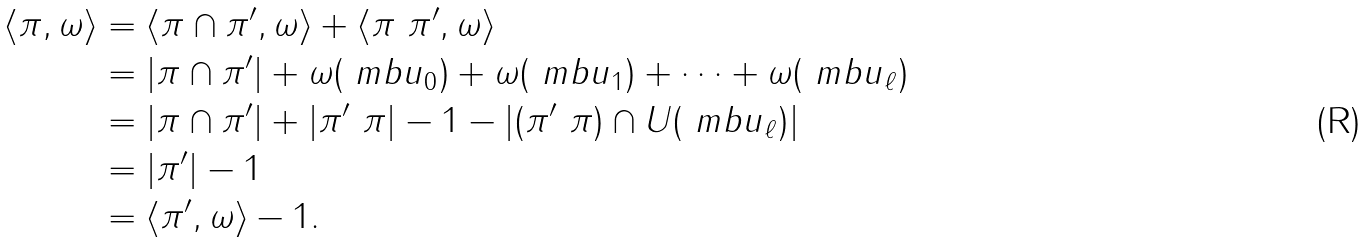<formula> <loc_0><loc_0><loc_500><loc_500>\langle \pi , \omega \rangle & = \langle \pi \cap \pi ^ { \prime } , \omega \rangle + \langle \pi \ \pi ^ { \prime } , \omega \rangle \\ & = | \pi \cap \pi ^ { \prime } | + \omega ( \ m b { u } _ { 0 } ) + \omega ( \ m b { u } _ { 1 } ) + \dots + \omega ( \ m b { u } _ { \ell } ) \\ & = | \pi \cap \pi ^ { \prime } | + | \pi ^ { \prime } \ \pi | - 1 - | ( \pi ^ { \prime } \ \pi ) \cap U ( \ m b { u } _ { \ell } ) | \\ & = | \pi ^ { \prime } | - 1 \\ & = \langle \pi ^ { \prime } , \omega \rangle - 1 .</formula> 